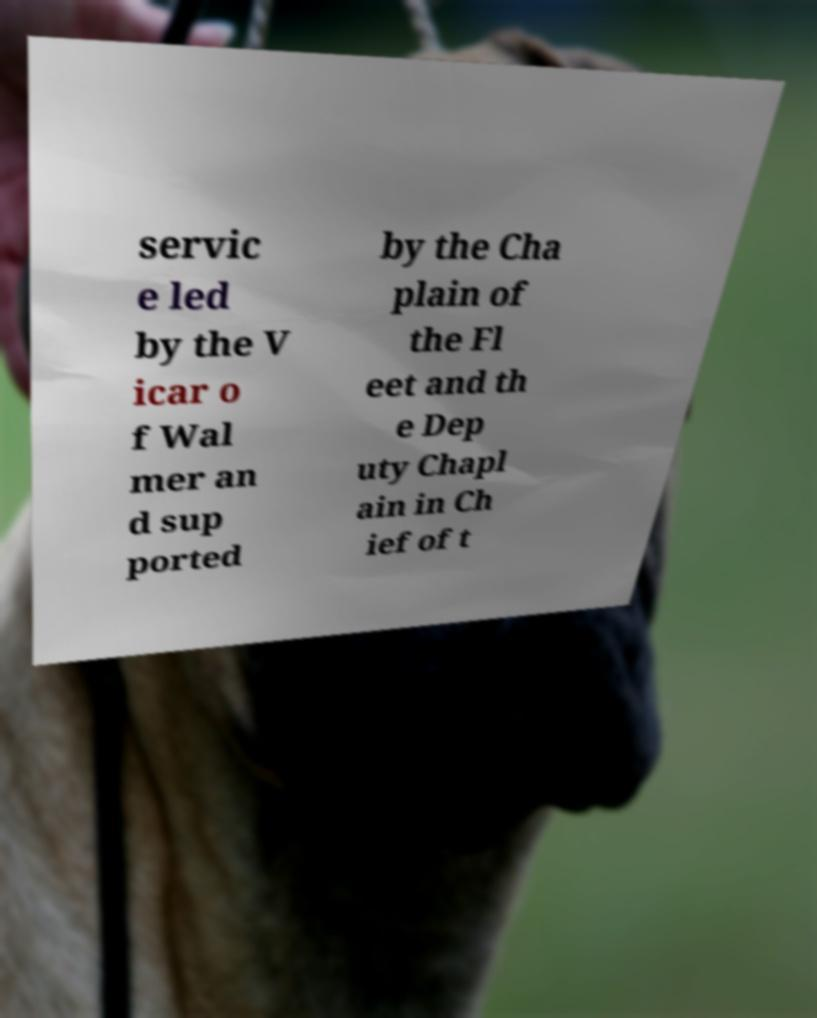For documentation purposes, I need the text within this image transcribed. Could you provide that? servic e led by the V icar o f Wal mer an d sup ported by the Cha plain of the Fl eet and th e Dep uty Chapl ain in Ch ief of t 